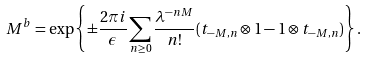Convert formula to latex. <formula><loc_0><loc_0><loc_500><loc_500>M ^ { b } = \exp \left \{ \pm \frac { 2 \pi i } { \epsilon } \sum _ { n \geq 0 } \frac { \lambda ^ { - n M } } { n ! } ( t _ { - M , n } \otimes 1 - 1 \otimes t _ { - M , n } ) \right \} .</formula> 